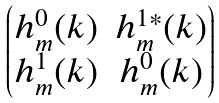<formula> <loc_0><loc_0><loc_500><loc_500>\begin{pmatrix} h ^ { 0 } _ { m } ( k ) & h ^ { 1 * } _ { m } ( k ) \\ h ^ { 1 } _ { m } ( k ) & h ^ { 0 } _ { m } ( k ) \end{pmatrix}</formula> 